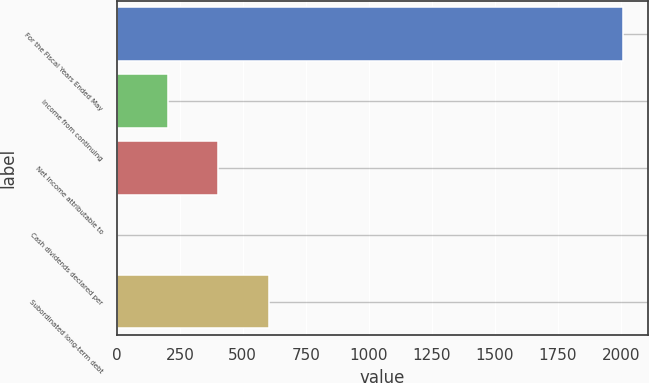Convert chart to OTSL. <chart><loc_0><loc_0><loc_500><loc_500><bar_chart><fcel>For the Fiscal Years Ended May<fcel>Income from continuing<fcel>Net income attributable to<fcel>Cash dividends declared per<fcel>Subordinated long-term debt<nl><fcel>2008<fcel>201.48<fcel>402.21<fcel>0.75<fcel>602.93<nl></chart> 